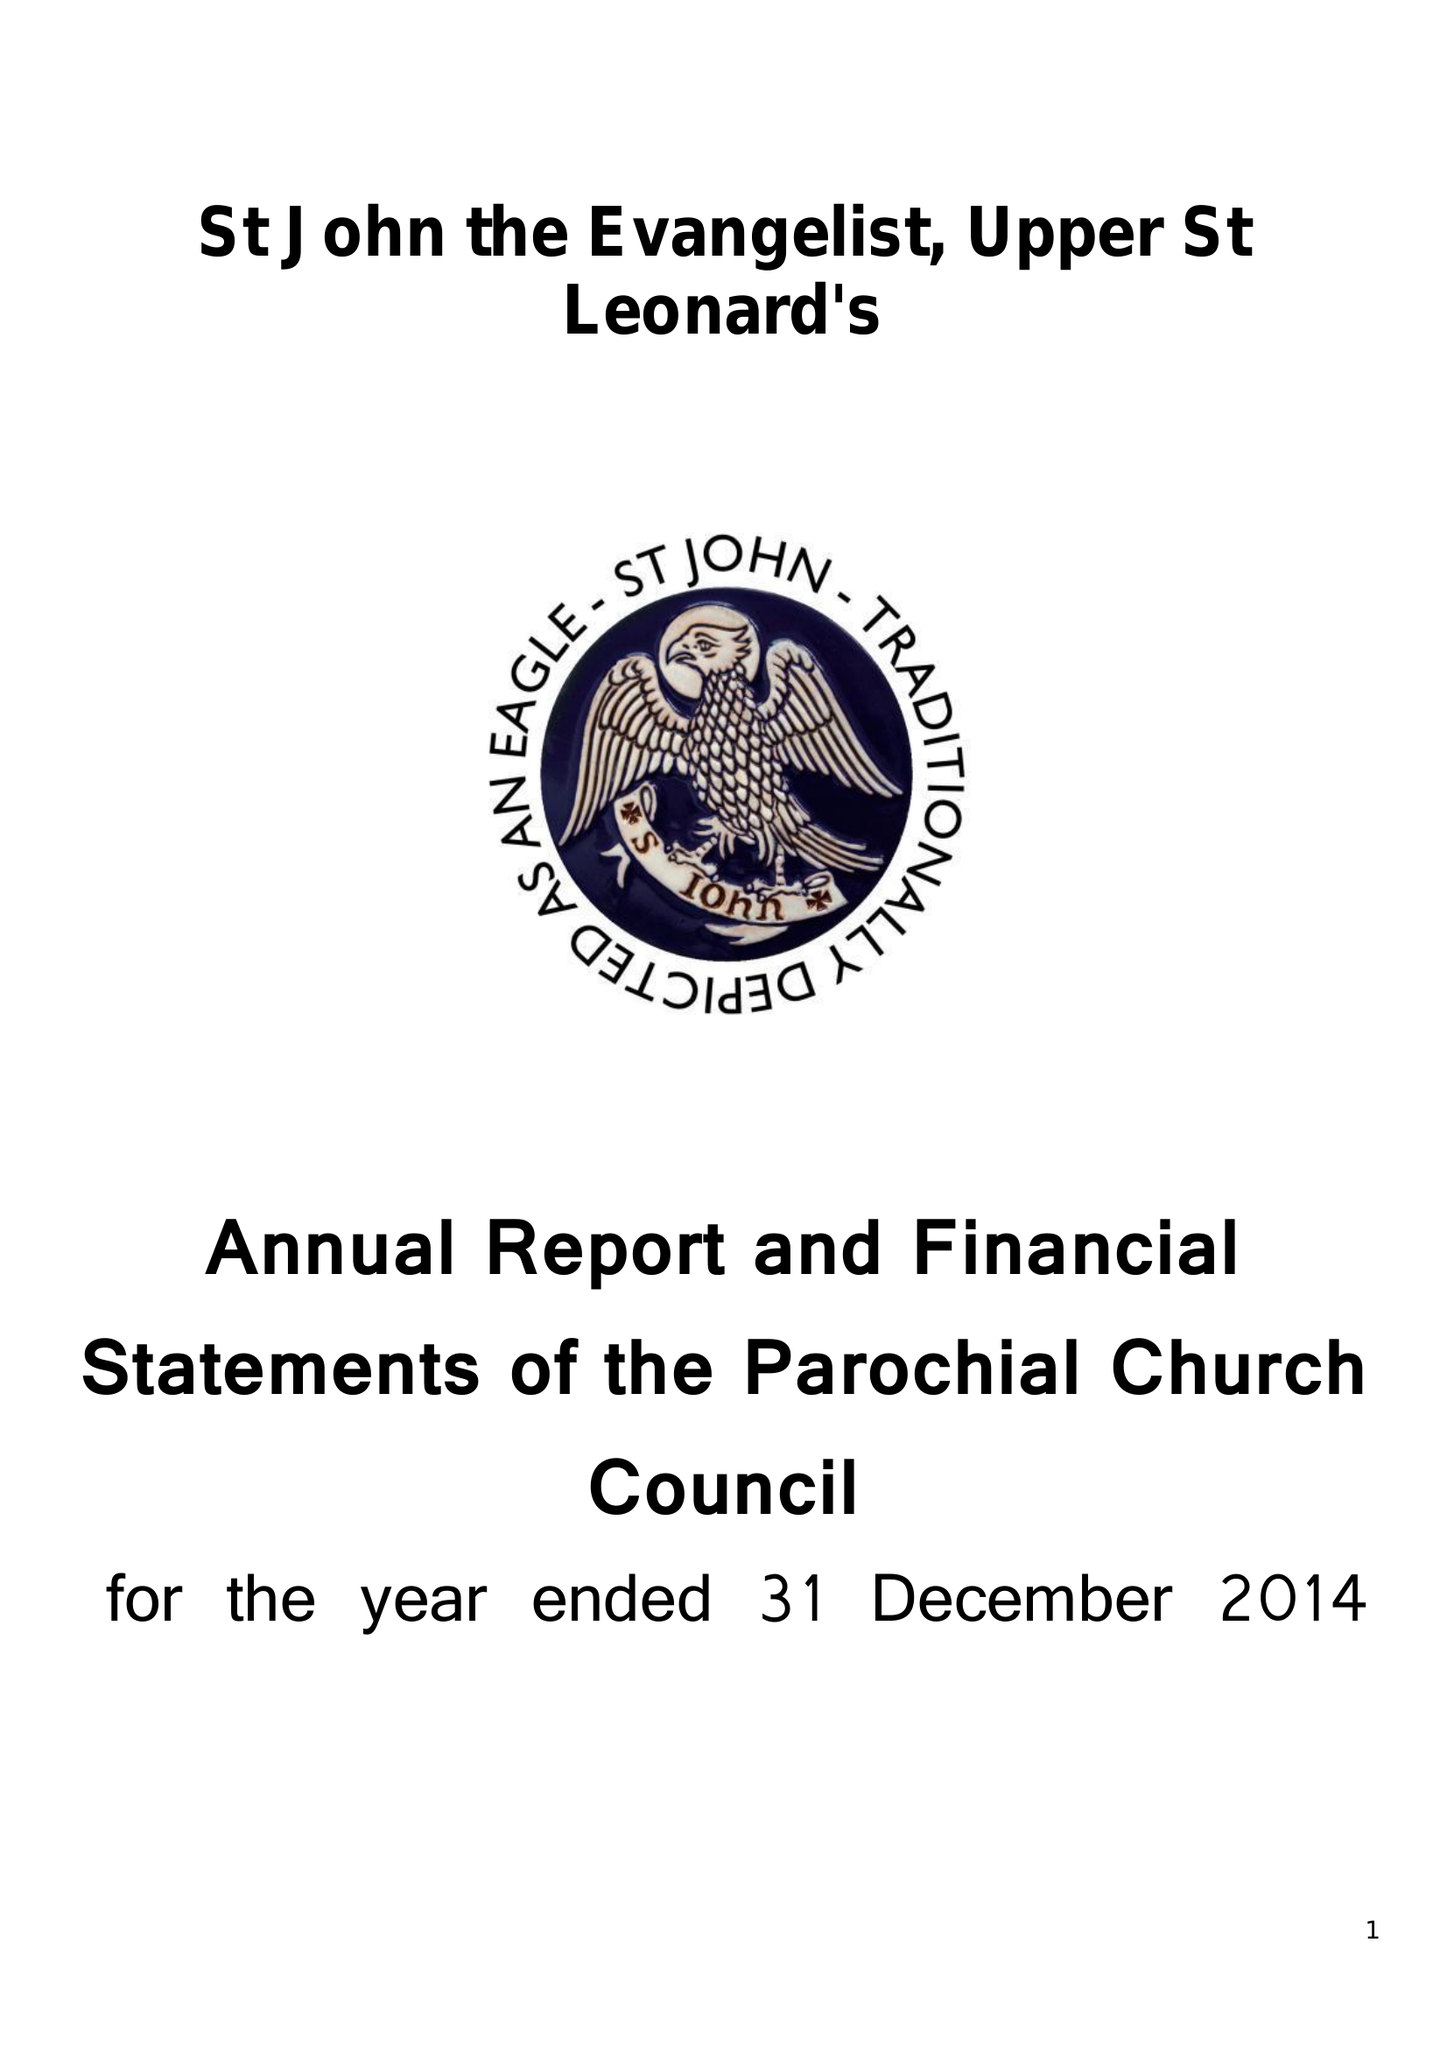What is the value for the report_date?
Answer the question using a single word or phrase. 2014-12-31 